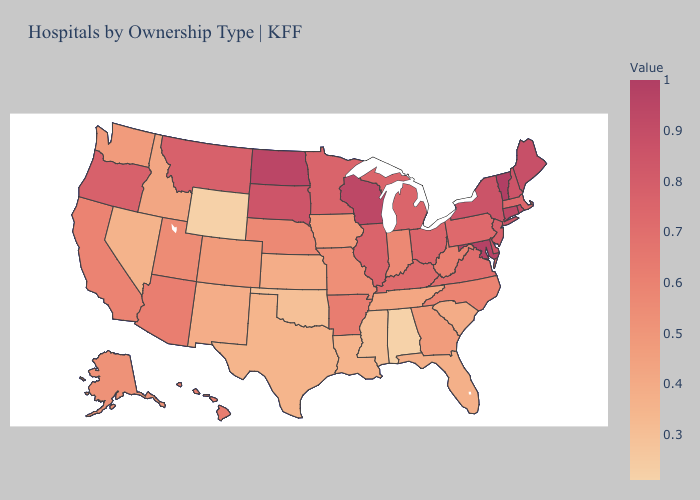Is the legend a continuous bar?
Write a very short answer. Yes. Does New York have the highest value in the Northeast?
Quick response, please. No. Does Vermont have the highest value in the USA?
Keep it brief. Yes. Which states have the highest value in the USA?
Be succinct. Vermont. Does Connecticut have the lowest value in the USA?
Give a very brief answer. No. Does Montana have the highest value in the West?
Be succinct. Yes. 